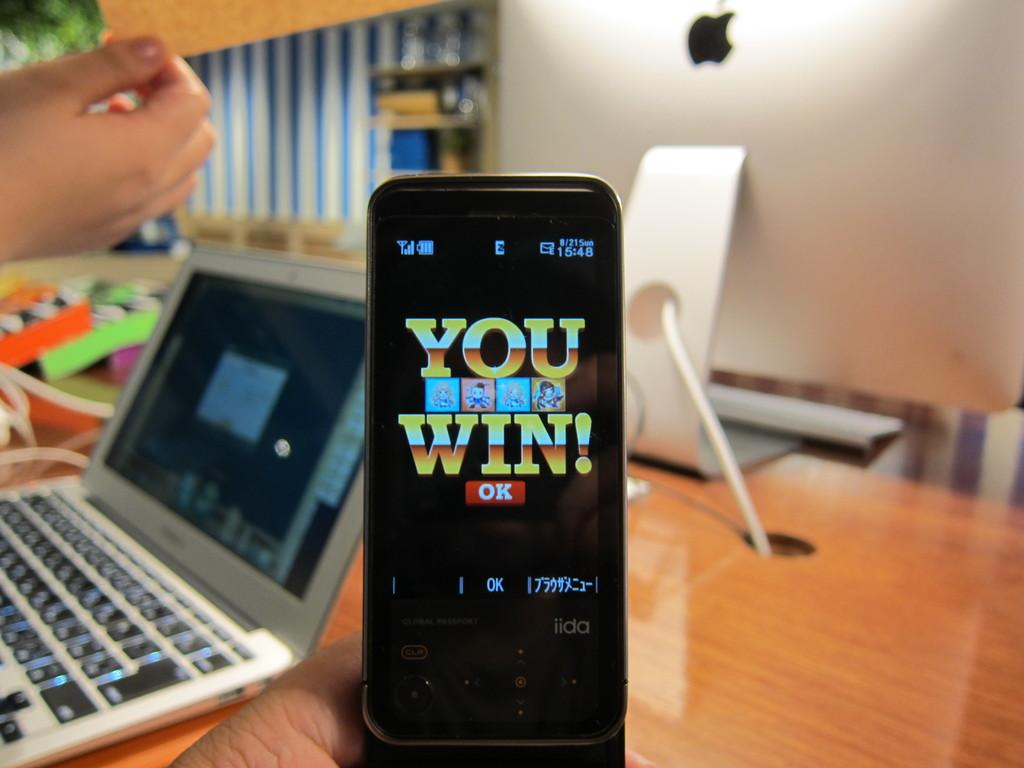Provide a one-sentence caption for the provided image. A small cell phone is being held up that says You Win. 